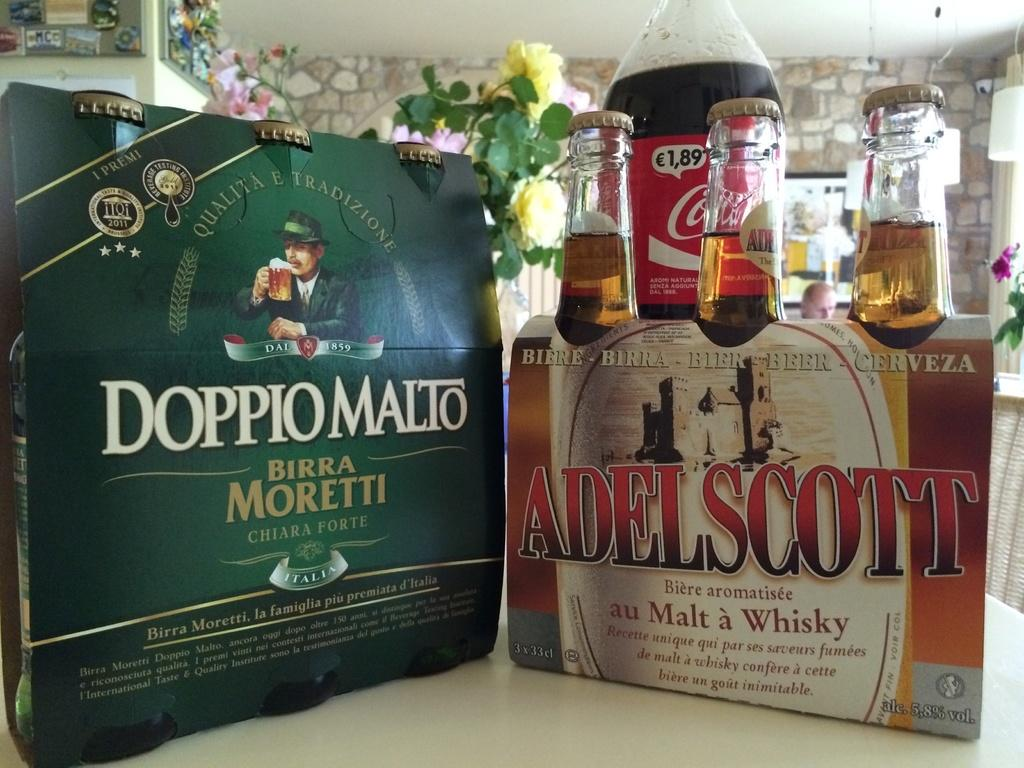<image>
Give a short and clear explanation of the subsequent image. Two six packs of DoppioMalto and Adelscott Malt whisky 